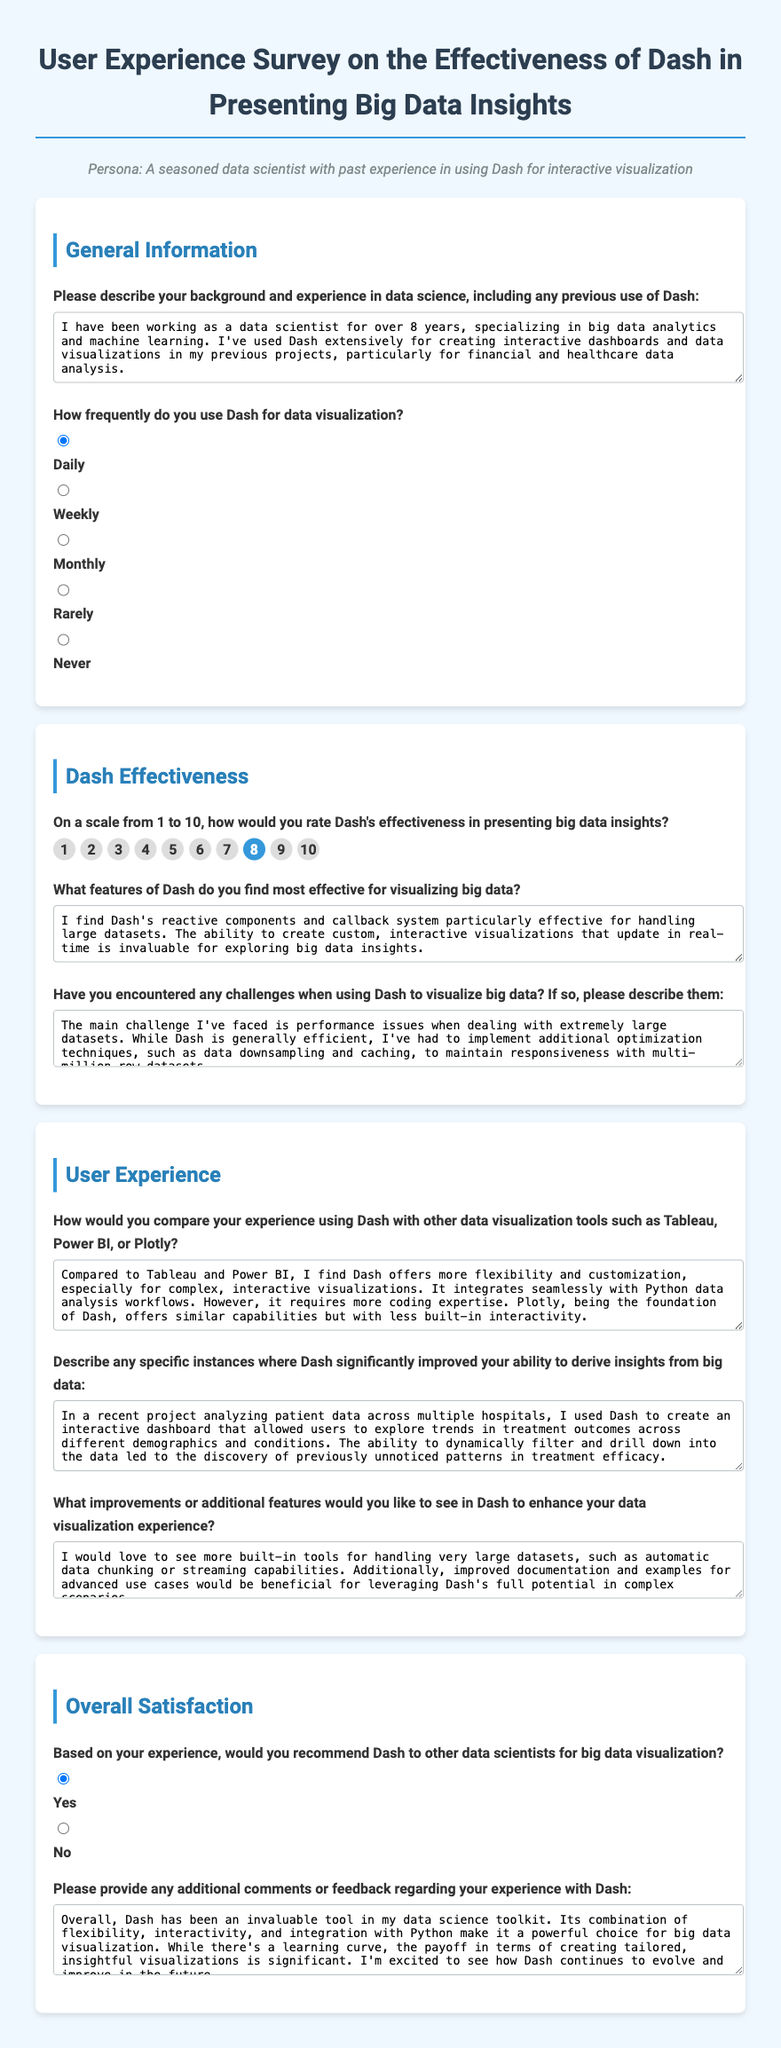What is the title of the survey? The title of the survey is found at the top of the document, indicating its focus on user experience regarding Dash.
Answer: User Experience Survey on the Effectiveness of Dash in Presenting Big Data Insights How many years of experience does the respondent have in data science? The respondent's experience in data science is mentioned in the first question response.
Answer: over 8 years What rating did the respondent give for Dash's effectiveness in presenting big data insights? The respondent's effectiveness rating for Dash is found in the rating section of the document.
Answer: 8 Which feature of Dash does the respondent find most effective? The most effective feature mentioned by the respondent can be found in their response about Dash features.
Answer: reactive components and callback system What is the main challenge faced when using Dash for visualizing big data? The specific challenge encountered by the respondent is described in their response to question five.
Answer: performance issues Did the respondent recommend Dash to other data scientists? The recommendation status is provided in the final section of the survey, focusing on overall satisfaction.
Answer: Yes What additional features does the respondent desire in Dash? The respondent’s suggestions for Dash improvements can be found in their answer regarding additional features.
Answer: automatic data chunking or streaming capabilities How does the respondent compare Dash with Tableau and Power BI? The comparison is provided in the section discussing user experience with Dash and other tools.
Answer: more flexibility and customization In what kind of project did Dash significantly improve insight discovery for the respondent? The specific instance where Dash improved insights is provided in the participant's answer related to project experience.
Answer: analyzing patient data across multiple hospitals 